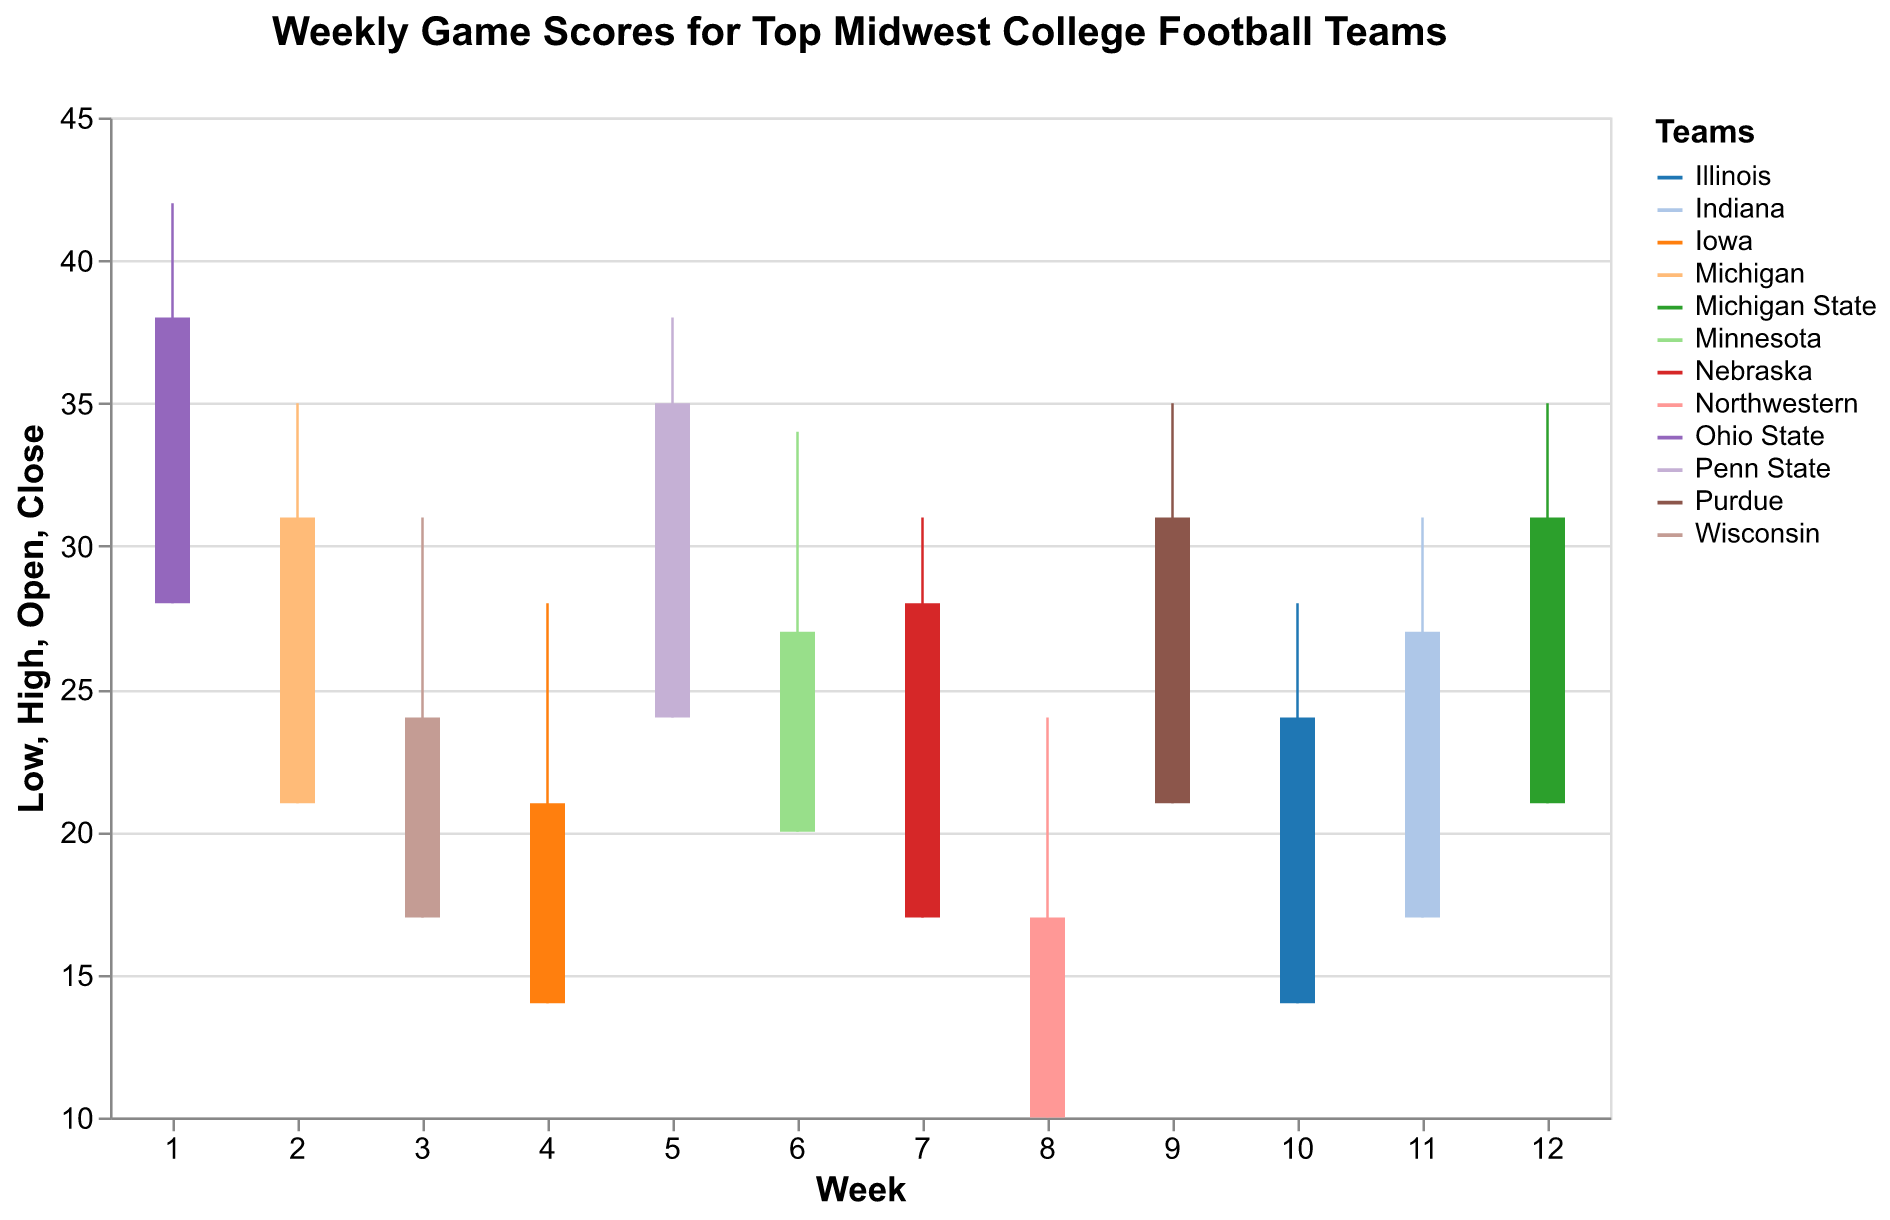What's the title of the chart? The title of the chart is located at the top and reads "Weekly Game Scores for Top Midwest College Football Teams".
Answer: Weekly Game Scores for Top Midwest College Football Teams How many teams are represented in this chart? The legend on the right side of the chart lists all the teams. Count the teams in the legend, which are: Ohio State, Michigan, Wisconsin, Iowa, Penn State, Minnesota, Nebraska, Northwestern, Purdue, Illinois, Indiana, and Michigan State.
Answer: 12 Which team had the highest score in any week? To find the highest score, look at the highest point on the vertical OHLC bars. Ohio State had the highest score with a peak of 42 in Week 1.
Answer: Ohio State What was the score range for Michigan in Week 2? The chart shows Michigan in Week 2 with Open = 21, High = 35, Low = 21, Close = 31. Therefore, the range is from 21 to 35.
Answer: 21 to 35 How did Wisconsin's final score (Close) compare to its initial score (Open) in Week 3? For Wisconsin in Week 3, the Open score is 17 and the Close score is 24. Compare these two numbers.
Answer: Increased by 7 Which team had the lowest scoring game in any week? Find the lowest point on the chart, which is Northwestern's score in Week 8 with a low score of 10.
Answer: Northwestern During which week did Penn State play, and what were their scores? Find Penn State in the legend and locate their bar in the corresponding week. Penn State played in Week 5 with scores: Open = 24, High = 38, Low = 24, Close = 35.
Answer: Week 5, Open = 24, High = 38, Low = 24, Close = 35 Which team showed the most volatility in their scores? Volatility in this context can be interpreted as the largest range between High and Low scores. Look for the team with the largest vertical line, which is Ohio State with a range of 42 - 28 = 14 points.
Answer: Ohio State How many teams closed their week with a score higher than they opened? Check each team's Open vs. Close; the teams that closed higher are Ohio State, Michigan, Penn State, Nebraska, Indiana, and Wisconsin. Count these teams.
Answer: 6 Which team's Open and Close scores were equal in any week? Analyzing all the weeks, no team's Open and Close scores are the same in any week.
Answer: None 